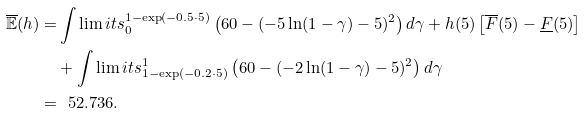Convert formula to latex. <formula><loc_0><loc_0><loc_500><loc_500>\overline { \mathbb { E } } ( h ) = & \int \lim i t s _ { 0 } ^ { 1 - \exp ( - 0 . 5 \cdot 5 ) } \left ( 6 0 - ( - 5 \ln ( 1 - \gamma ) - 5 ) ^ { 2 } \right ) d \gamma + h ( 5 ) \left [ \overline { F } ( 5 ) - \underline { F } ( 5 ) \right ] \\ & + \int \lim i t s _ { 1 - \exp ( - 0 . 2 \cdot 5 ) } ^ { 1 } \left ( 6 0 - ( - 2 \ln ( 1 - \gamma ) - 5 ) ^ { 2 } \right ) d \gamma \\ = & \ \ 5 2 . 7 3 6 .</formula> 